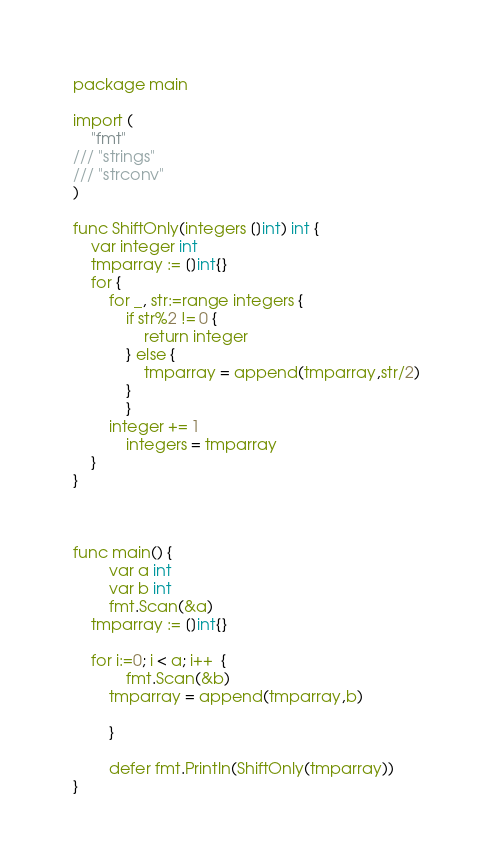Convert code to text. <code><loc_0><loc_0><loc_500><loc_500><_Go_>package main

import (
	"fmt"
///	"strings"
///	"strconv"
)

func ShiftOnly(integers []int) int {
	var integer int
	tmparray := []int{}
	for {
		for _, str:=range integers {
			if str%2 != 0 {
				return integer
			} else {
				tmparray = append(tmparray,str/2)
			}
        	}
		integer += 1
	        integers = tmparray	
	}	
}



func main() {
        var a int
        var b int
        fmt.Scan(&a)
	tmparray := []int{}
        
	for i:=0; i < a; i++  {
        	fmt.Scan(&b)
		tmparray = append(tmparray,b)

        }

        defer fmt.Println(ShiftOnly(tmparray))
}</code> 